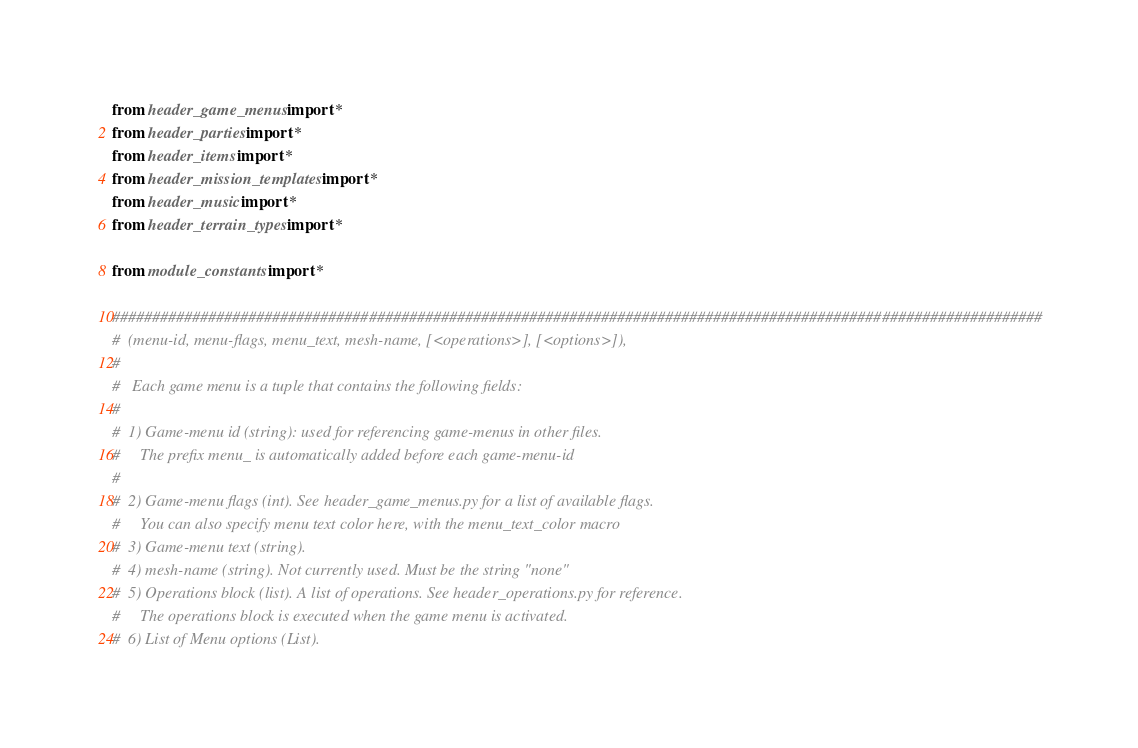Convert code to text. <code><loc_0><loc_0><loc_500><loc_500><_Python_>from header_game_menus import *
from header_parties import *
from header_items import *
from header_mission_templates import *
from header_music import *
from header_terrain_types import *

from module_constants import *

####################################################################################################################
#  (menu-id, menu-flags, menu_text, mesh-name, [<operations>], [<options>]),
#
#   Each game menu is a tuple that contains the following fields:
#
#  1) Game-menu id (string): used for referencing game-menus in other files.
#     The prefix menu_ is automatically added before each game-menu-id
#
#  2) Game-menu flags (int). See header_game_menus.py for a list of available flags.
#     You can also specify menu text color here, with the menu_text_color macro
#  3) Game-menu text (string).
#  4) mesh-name (string). Not currently used. Must be the string "none"
#  5) Operations block (list). A list of operations. See header_operations.py for reference.
#     The operations block is executed when the game menu is activated.
#  6) List of Menu options (List).</code> 